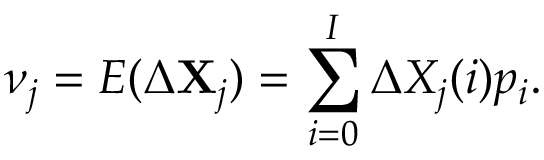Convert formula to latex. <formula><loc_0><loc_0><loc_500><loc_500>\nu _ { j } = E ( \Delta X _ { j } ) = \sum _ { i = 0 } ^ { I } \Delta X _ { j } ( i ) p _ { i } .</formula> 